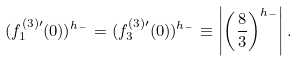<formula> <loc_0><loc_0><loc_500><loc_500>( f ^ { ( 3 ) \prime } _ { 1 } ( 0 ) ) ^ { h _ { - } } = ( f ^ { ( 3 ) \prime } _ { 3 } ( 0 ) ) ^ { h _ { - } } \equiv \left | \left ( \frac { 8 } { 3 } \right ) ^ { h _ { - } } \right | .</formula> 